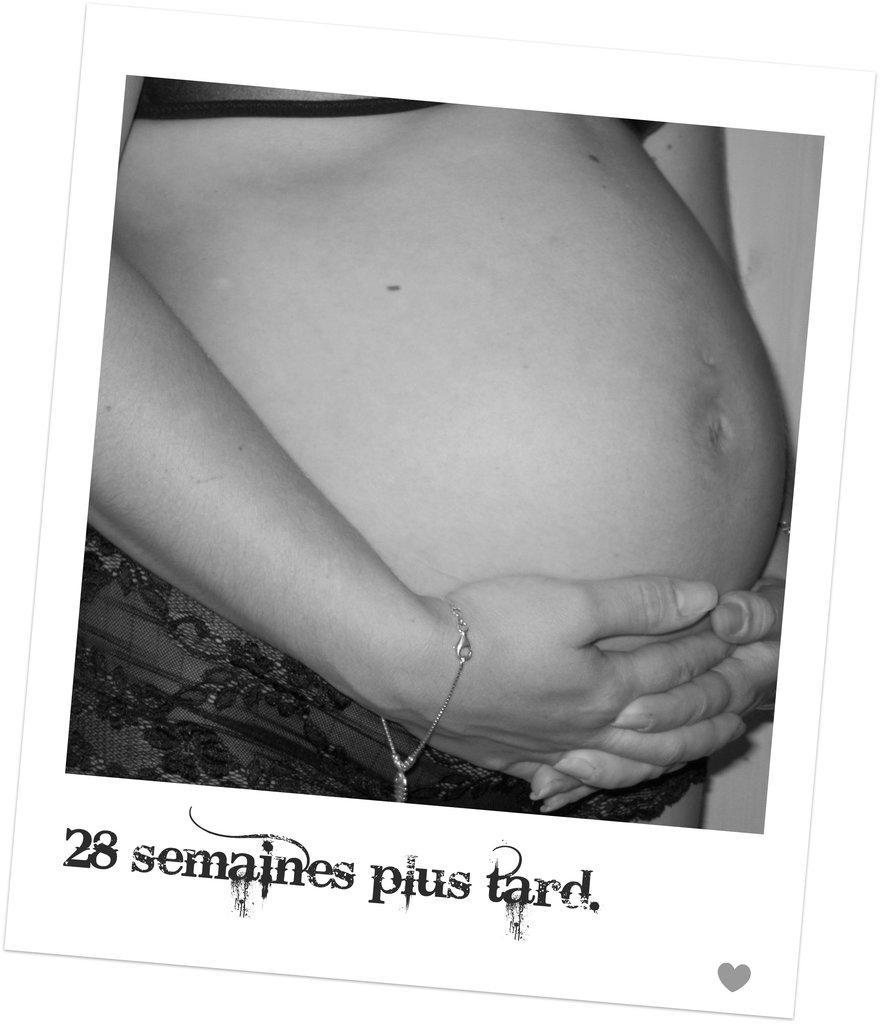In one or two sentences, can you explain what this image depicts? Here we can see stomach and hands of a person. 